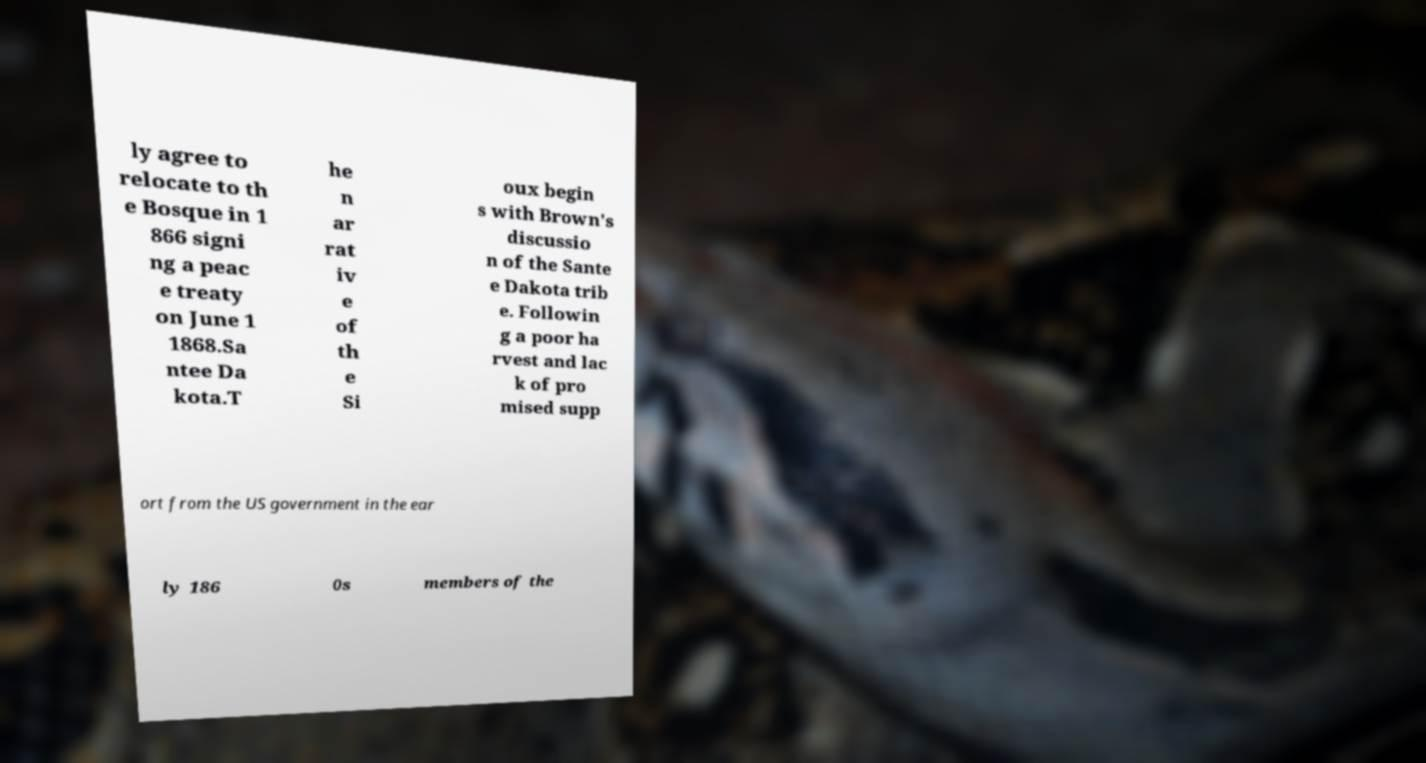Please read and relay the text visible in this image. What does it say? ly agree to relocate to th e Bosque in 1 866 signi ng a peac e treaty on June 1 1868.Sa ntee Da kota.T he n ar rat iv e of th e Si oux begin s with Brown's discussio n of the Sante e Dakota trib e. Followin g a poor ha rvest and lac k of pro mised supp ort from the US government in the ear ly 186 0s members of the 